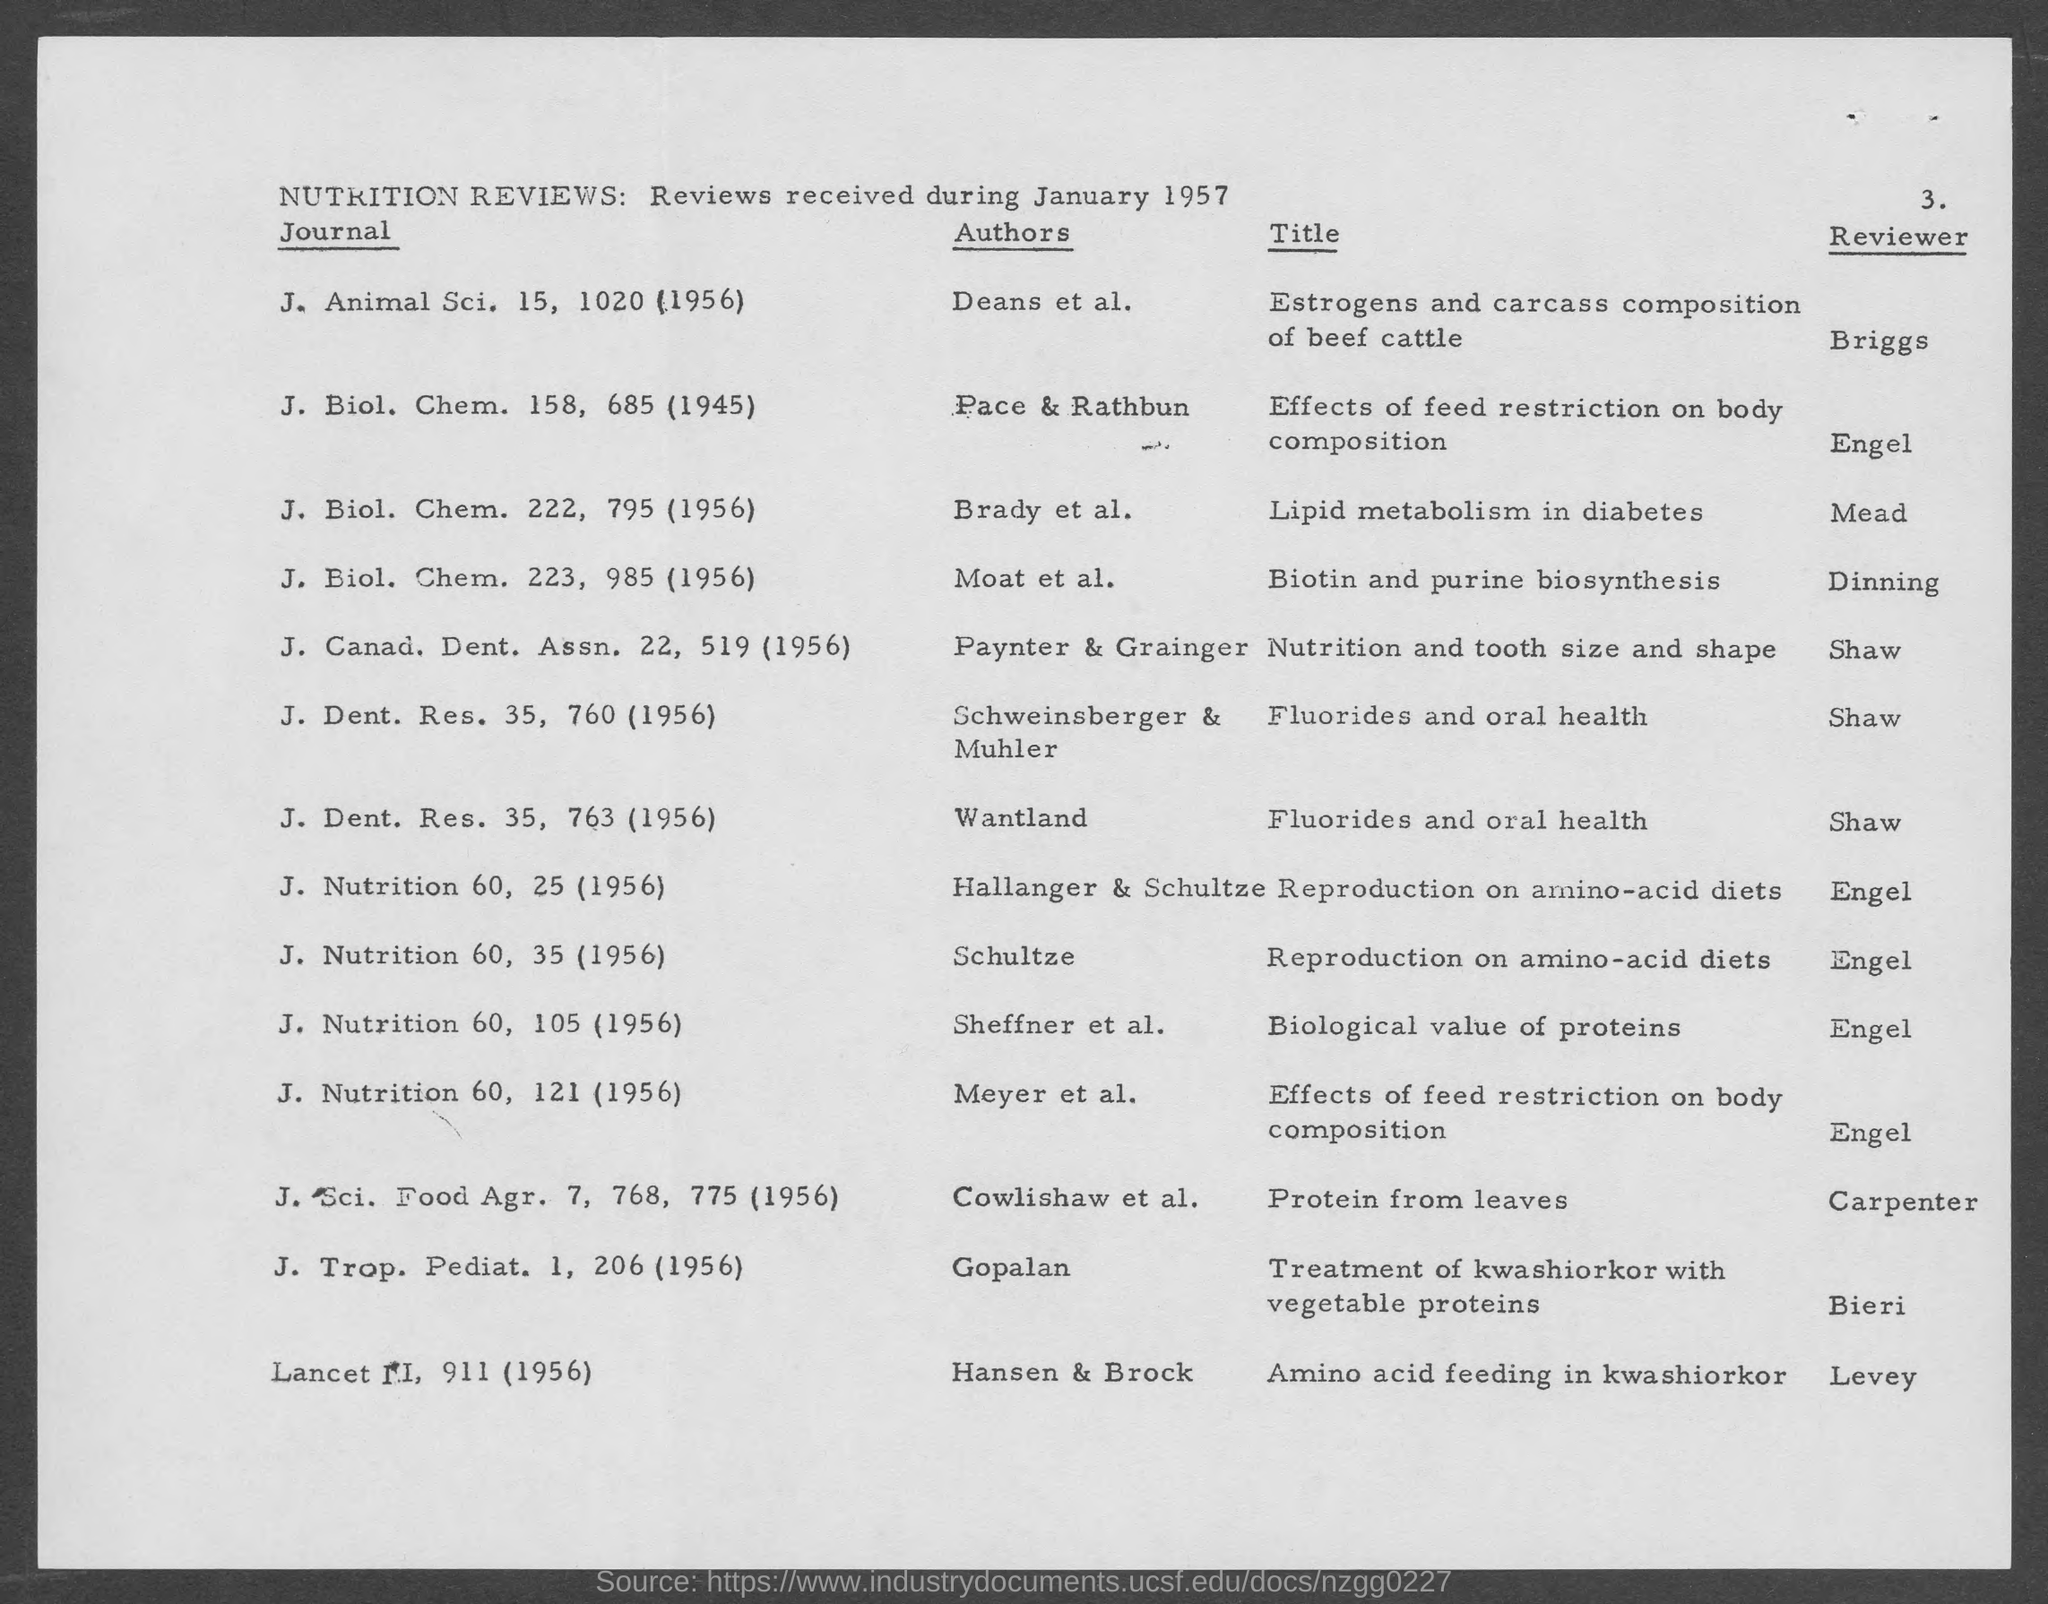Who is the reviewer of the journal J. Nutrition 60, 35 (1956)?
 engel 